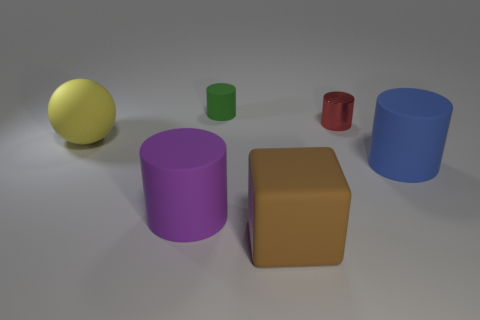Is the number of matte cylinders on the left side of the purple thing less than the number of small red cylinders?
Your response must be concise. Yes. How big is the rubber cylinder that is on the right side of the object that is in front of the purple cylinder?
Ensure brevity in your answer.  Large. How many things are tiny cylinders or brown rubber cubes?
Offer a very short reply. 3. Are there any tiny matte cylinders of the same color as the rubber ball?
Provide a short and direct response. No. Is the number of objects less than the number of rubber things?
Offer a terse response. No. How many things are either blue matte cylinders or large matte objects that are left of the tiny green matte cylinder?
Your answer should be very brief. 3. Is there a green object made of the same material as the large blue thing?
Keep it short and to the point. Yes. There is a blue object that is the same size as the matte sphere; what is it made of?
Your answer should be very brief. Rubber. There is a tiny cylinder that is on the left side of the brown cube in front of the tiny red cylinder; what is its material?
Provide a short and direct response. Rubber. Does the matte object that is behind the big yellow thing have the same shape as the big brown matte thing?
Your response must be concise. No. 